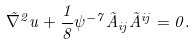Convert formula to latex. <formula><loc_0><loc_0><loc_500><loc_500>\tilde { \nabla } ^ { 2 } u + \frac { 1 } { 8 } \psi ^ { - 7 } \tilde { A } _ { i j } \tilde { A } ^ { i j } = 0 .</formula> 